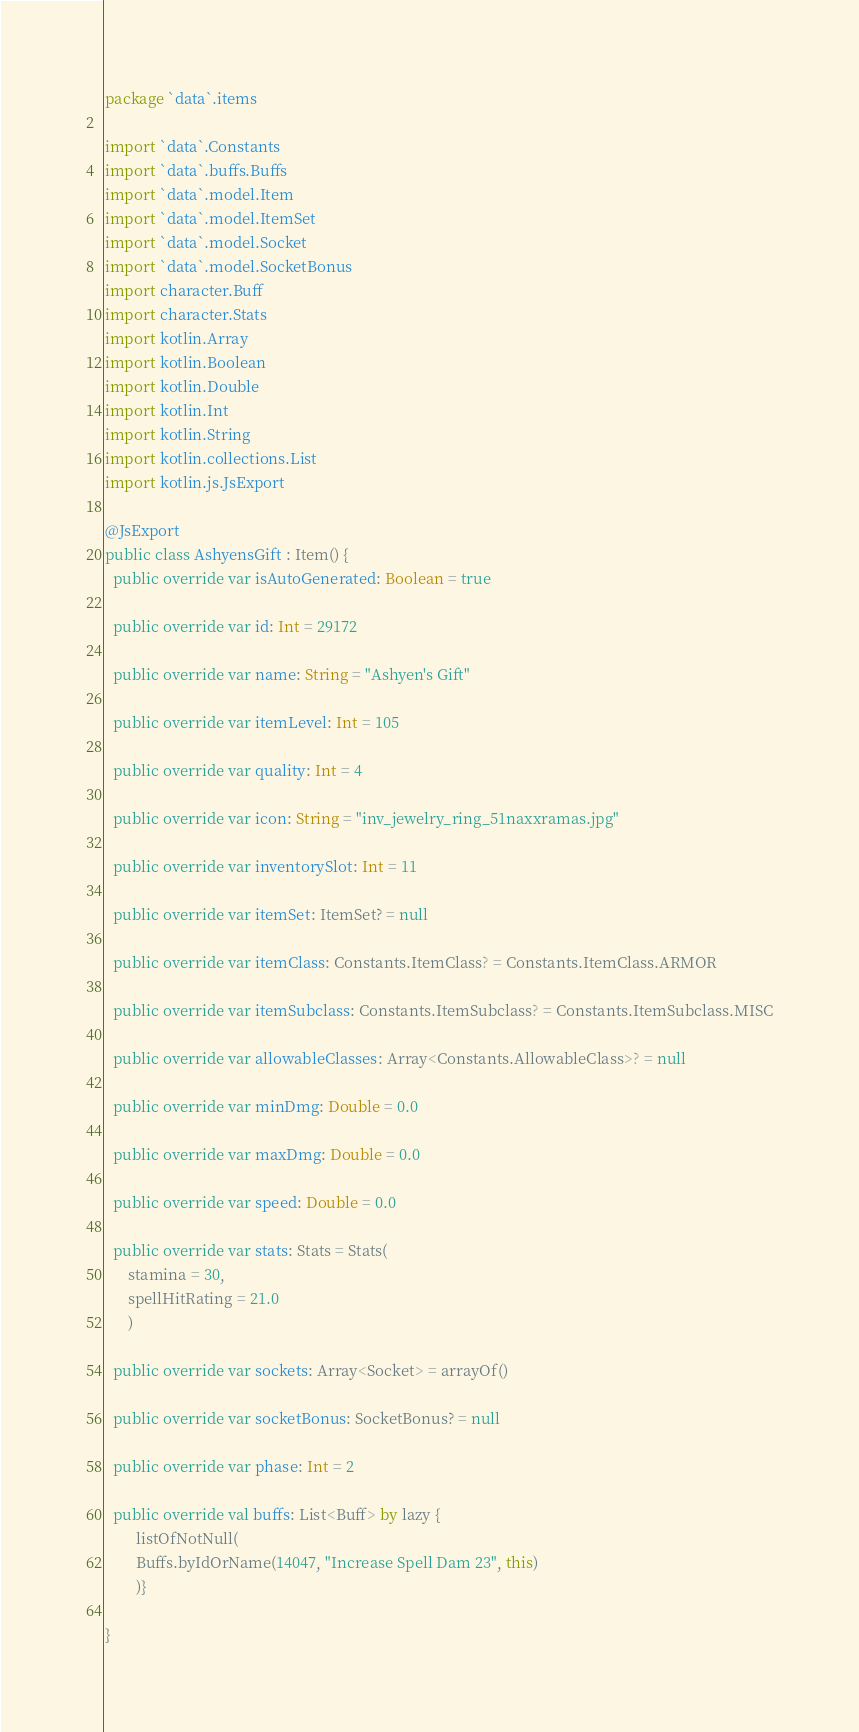<code> <loc_0><loc_0><loc_500><loc_500><_Kotlin_>package `data`.items

import `data`.Constants
import `data`.buffs.Buffs
import `data`.model.Item
import `data`.model.ItemSet
import `data`.model.Socket
import `data`.model.SocketBonus
import character.Buff
import character.Stats
import kotlin.Array
import kotlin.Boolean
import kotlin.Double
import kotlin.Int
import kotlin.String
import kotlin.collections.List
import kotlin.js.JsExport

@JsExport
public class AshyensGift : Item() {
  public override var isAutoGenerated: Boolean = true

  public override var id: Int = 29172

  public override var name: String = "Ashyen's Gift"

  public override var itemLevel: Int = 105

  public override var quality: Int = 4

  public override var icon: String = "inv_jewelry_ring_51naxxramas.jpg"

  public override var inventorySlot: Int = 11

  public override var itemSet: ItemSet? = null

  public override var itemClass: Constants.ItemClass? = Constants.ItemClass.ARMOR

  public override var itemSubclass: Constants.ItemSubclass? = Constants.ItemSubclass.MISC

  public override var allowableClasses: Array<Constants.AllowableClass>? = null

  public override var minDmg: Double = 0.0

  public override var maxDmg: Double = 0.0

  public override var speed: Double = 0.0

  public override var stats: Stats = Stats(
      stamina = 30,
      spellHitRating = 21.0
      )

  public override var sockets: Array<Socket> = arrayOf()

  public override var socketBonus: SocketBonus? = null

  public override var phase: Int = 2

  public override val buffs: List<Buff> by lazy {
        listOfNotNull(
        Buffs.byIdOrName(14047, "Increase Spell Dam 23", this)
        )}

}
</code> 